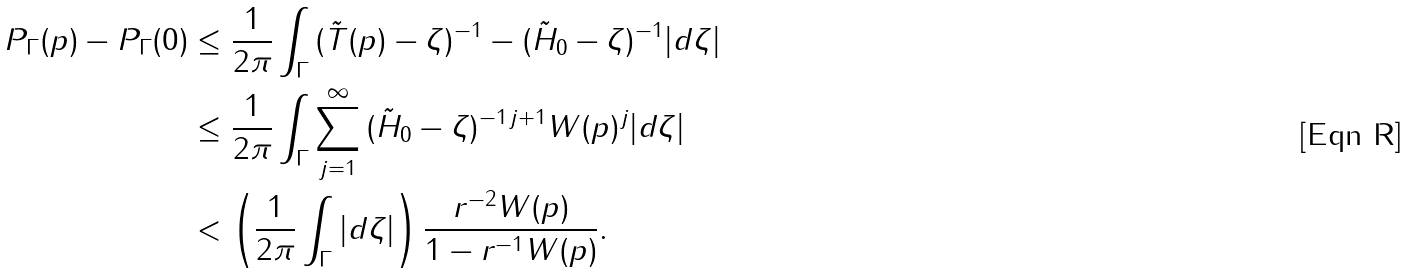<formula> <loc_0><loc_0><loc_500><loc_500>\| P _ { \Gamma } ( p ) - P _ { \Gamma } ( 0 ) \| & \leq \frac { 1 } { 2 \pi } \int _ { \Gamma } \| ( \tilde { T } ( p ) - \zeta ) ^ { - 1 } - ( \tilde { H } _ { 0 } - \zeta ) ^ { - 1 } \| | d \zeta | \\ & \leq \frac { 1 } { 2 \pi } \int _ { \Gamma } \sum _ { j = 1 } ^ { \infty } \| ( \tilde { H } _ { 0 } - \zeta ) ^ { - 1 } \| ^ { j + 1 } \| W ( p ) \| ^ { j } | d \zeta | \\ & < \left ( \frac { 1 } { 2 \pi } \int _ { \Gamma } | d \zeta | \right ) \frac { r ^ { - 2 } \| W ( p ) \| } { 1 - r ^ { - 1 } \| W ( p ) \| } .</formula> 